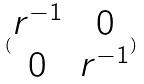<formula> <loc_0><loc_0><loc_500><loc_500>( \begin{matrix} r ^ { - 1 } & 0 \\ 0 & r ^ { - 1 } \end{matrix} )</formula> 